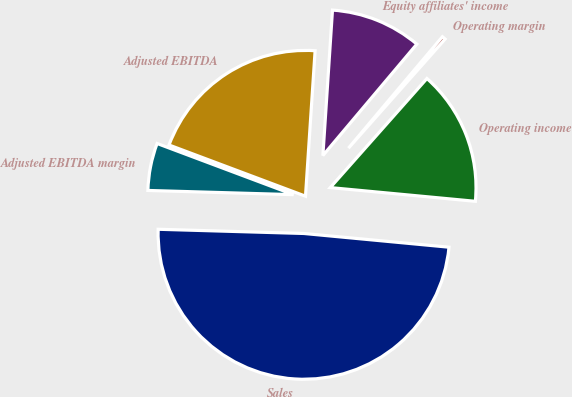Convert chart to OTSL. <chart><loc_0><loc_0><loc_500><loc_500><pie_chart><fcel>Sales<fcel>Operating income<fcel>Operating margin<fcel>Equity affiliates' income<fcel>Adjusted EBITDA<fcel>Adjusted EBITDA margin<nl><fcel>48.96%<fcel>14.96%<fcel>0.39%<fcel>10.1%<fcel>20.34%<fcel>5.25%<nl></chart> 